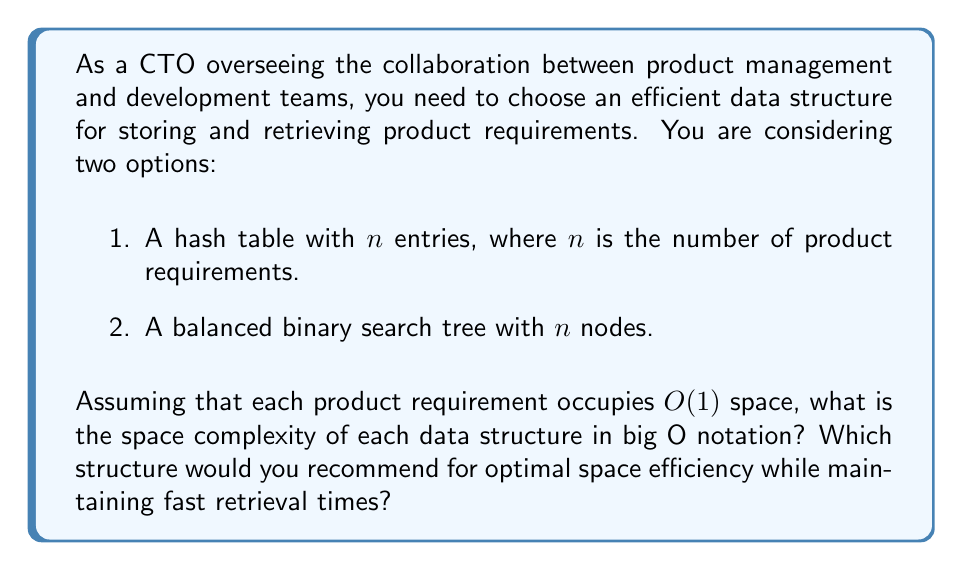Show me your answer to this math problem. Let's analyze the space complexity of each data structure:

1. Hash Table:
   - Each entry in the hash table stores a product requirement, which occupies $O(1)$ space.
   - There are $n$ entries in total.
   - The hash table itself requires additional space for its internal structure, typically $O(n)$ for a well-implemented hash table.
   - Total space complexity: $O(n) + O(n) = O(n)$

2. Balanced Binary Search Tree:
   - Each node in the tree stores a product requirement, which occupies $O(1)$ space.
   - There are $n$ nodes in total.
   - Each node also requires additional space for pointers to its children and potentially its parent, which is still $O(1)$ per node.
   - Total space complexity: $O(n)$

Both data structures have a space complexity of $O(n)$, which means they scale linearly with the number of product requirements.

Regarding the recommendation:
- Both structures offer $O(n)$ space complexity, so they are equally efficient in terms of space usage.
- Hash tables typically provide $O(1)$ average-case time complexity for insertions, deletions, and lookups, while balanced binary search trees offer $O(\log n)$ time complexity for these operations.
- Hash tables may have better cache performance due to their contiguous memory allocation, which can be beneficial for frequent access patterns.

Given that both structures have the same space complexity, the choice would depend on other factors such as:
1. The need for ordered traversal of requirements (BST is better for this).
2. The frequency of insertions, deletions, and lookups (Hash table is generally faster).
3. The importance of worst-case time complexity guarantees (BST provides consistent $O(\log n)$ performance).

For a CTO focused on collaboration and efficient product launches, the hash table might be the preferred choice due to its potentially faster average-case performance for retrievals, which could streamline communication between product management and development teams.
Answer: Both the hash table and the balanced binary search tree have a space complexity of $O(n)$, where $n$ is the number of product requirements. For optimal space efficiency while maintaining fast retrieval times, a hash table is recommended due to its $O(1)$ average-case time complexity for retrievals, which can enhance collaboration between product management and development teams. 